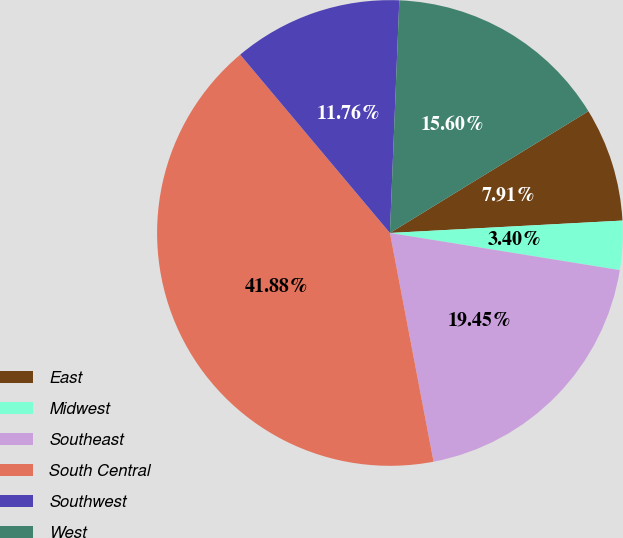Convert chart to OTSL. <chart><loc_0><loc_0><loc_500><loc_500><pie_chart><fcel>East<fcel>Midwest<fcel>Southeast<fcel>South Central<fcel>Southwest<fcel>West<nl><fcel>7.91%<fcel>3.4%<fcel>19.45%<fcel>41.88%<fcel>11.76%<fcel>15.6%<nl></chart> 